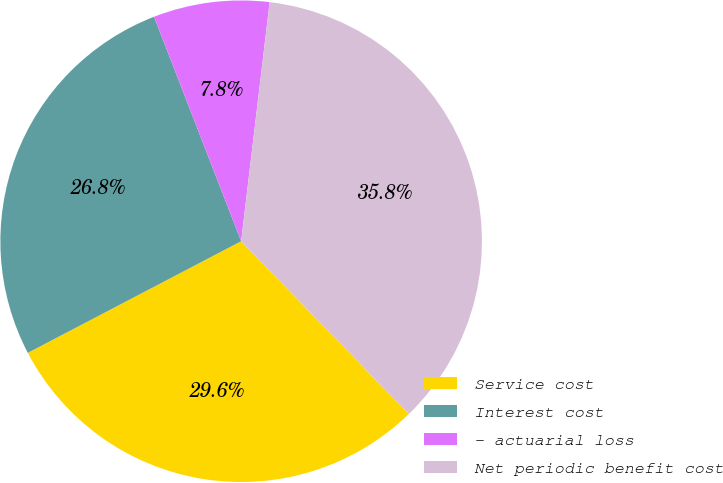Convert chart to OTSL. <chart><loc_0><loc_0><loc_500><loc_500><pie_chart><fcel>Service cost<fcel>Interest cost<fcel>- actuarial loss<fcel>Net periodic benefit cost<nl><fcel>29.59%<fcel>26.78%<fcel>7.78%<fcel>35.85%<nl></chart> 